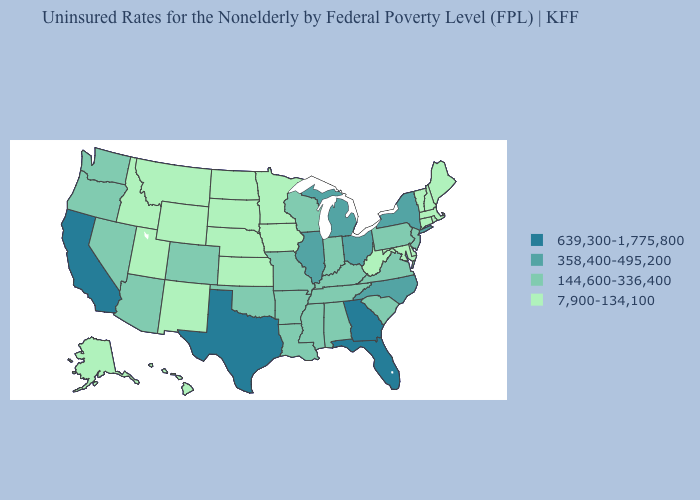Is the legend a continuous bar?
Concise answer only. No. Name the states that have a value in the range 7,900-134,100?
Concise answer only. Alaska, Connecticut, Delaware, Hawaii, Idaho, Iowa, Kansas, Maine, Maryland, Massachusetts, Minnesota, Montana, Nebraska, New Hampshire, New Mexico, North Dakota, Rhode Island, South Dakota, Utah, Vermont, West Virginia, Wyoming. Does Iowa have the same value as New Mexico?
Short answer required. Yes. What is the value of Hawaii?
Keep it brief. 7,900-134,100. What is the value of Massachusetts?
Short answer required. 7,900-134,100. Which states have the lowest value in the West?
Quick response, please. Alaska, Hawaii, Idaho, Montana, New Mexico, Utah, Wyoming. Among the states that border New Hampshire , which have the highest value?
Short answer required. Maine, Massachusetts, Vermont. Name the states that have a value in the range 639,300-1,775,800?
Concise answer only. California, Florida, Georgia, Texas. Name the states that have a value in the range 144,600-336,400?
Quick response, please. Alabama, Arizona, Arkansas, Colorado, Indiana, Kentucky, Louisiana, Mississippi, Missouri, Nevada, New Jersey, Oklahoma, Oregon, Pennsylvania, South Carolina, Tennessee, Virginia, Washington, Wisconsin. Name the states that have a value in the range 358,400-495,200?
Concise answer only. Illinois, Michigan, New York, North Carolina, Ohio. Name the states that have a value in the range 358,400-495,200?
Keep it brief. Illinois, Michigan, New York, North Carolina, Ohio. Name the states that have a value in the range 144,600-336,400?
Answer briefly. Alabama, Arizona, Arkansas, Colorado, Indiana, Kentucky, Louisiana, Mississippi, Missouri, Nevada, New Jersey, Oklahoma, Oregon, Pennsylvania, South Carolina, Tennessee, Virginia, Washington, Wisconsin. What is the value of New Mexico?
Concise answer only. 7,900-134,100. What is the value of Nebraska?
Quick response, please. 7,900-134,100. What is the highest value in states that border Colorado?
Answer briefly. 144,600-336,400. 